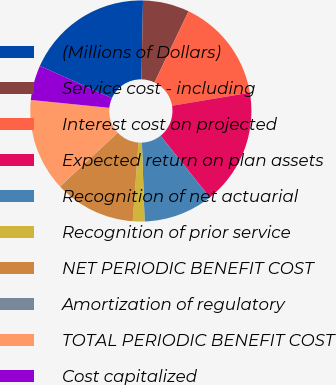Convert chart. <chart><loc_0><loc_0><loc_500><loc_500><pie_chart><fcel>(Millions of Dollars)<fcel>Service cost - including<fcel>Interest cost on projected<fcel>Expected return on plan assets<fcel>Recognition of net actuarial<fcel>Recognition of prior service<fcel>NET PERIODIC BENEFIT COST<fcel>Amortization of regulatory<fcel>TOTAL PERIODIC BENEFIT COST<fcel>Cost capitalized<nl><fcel>18.63%<fcel>6.79%<fcel>15.25%<fcel>16.94%<fcel>10.17%<fcel>1.71%<fcel>11.86%<fcel>0.02%<fcel>13.55%<fcel>5.09%<nl></chart> 